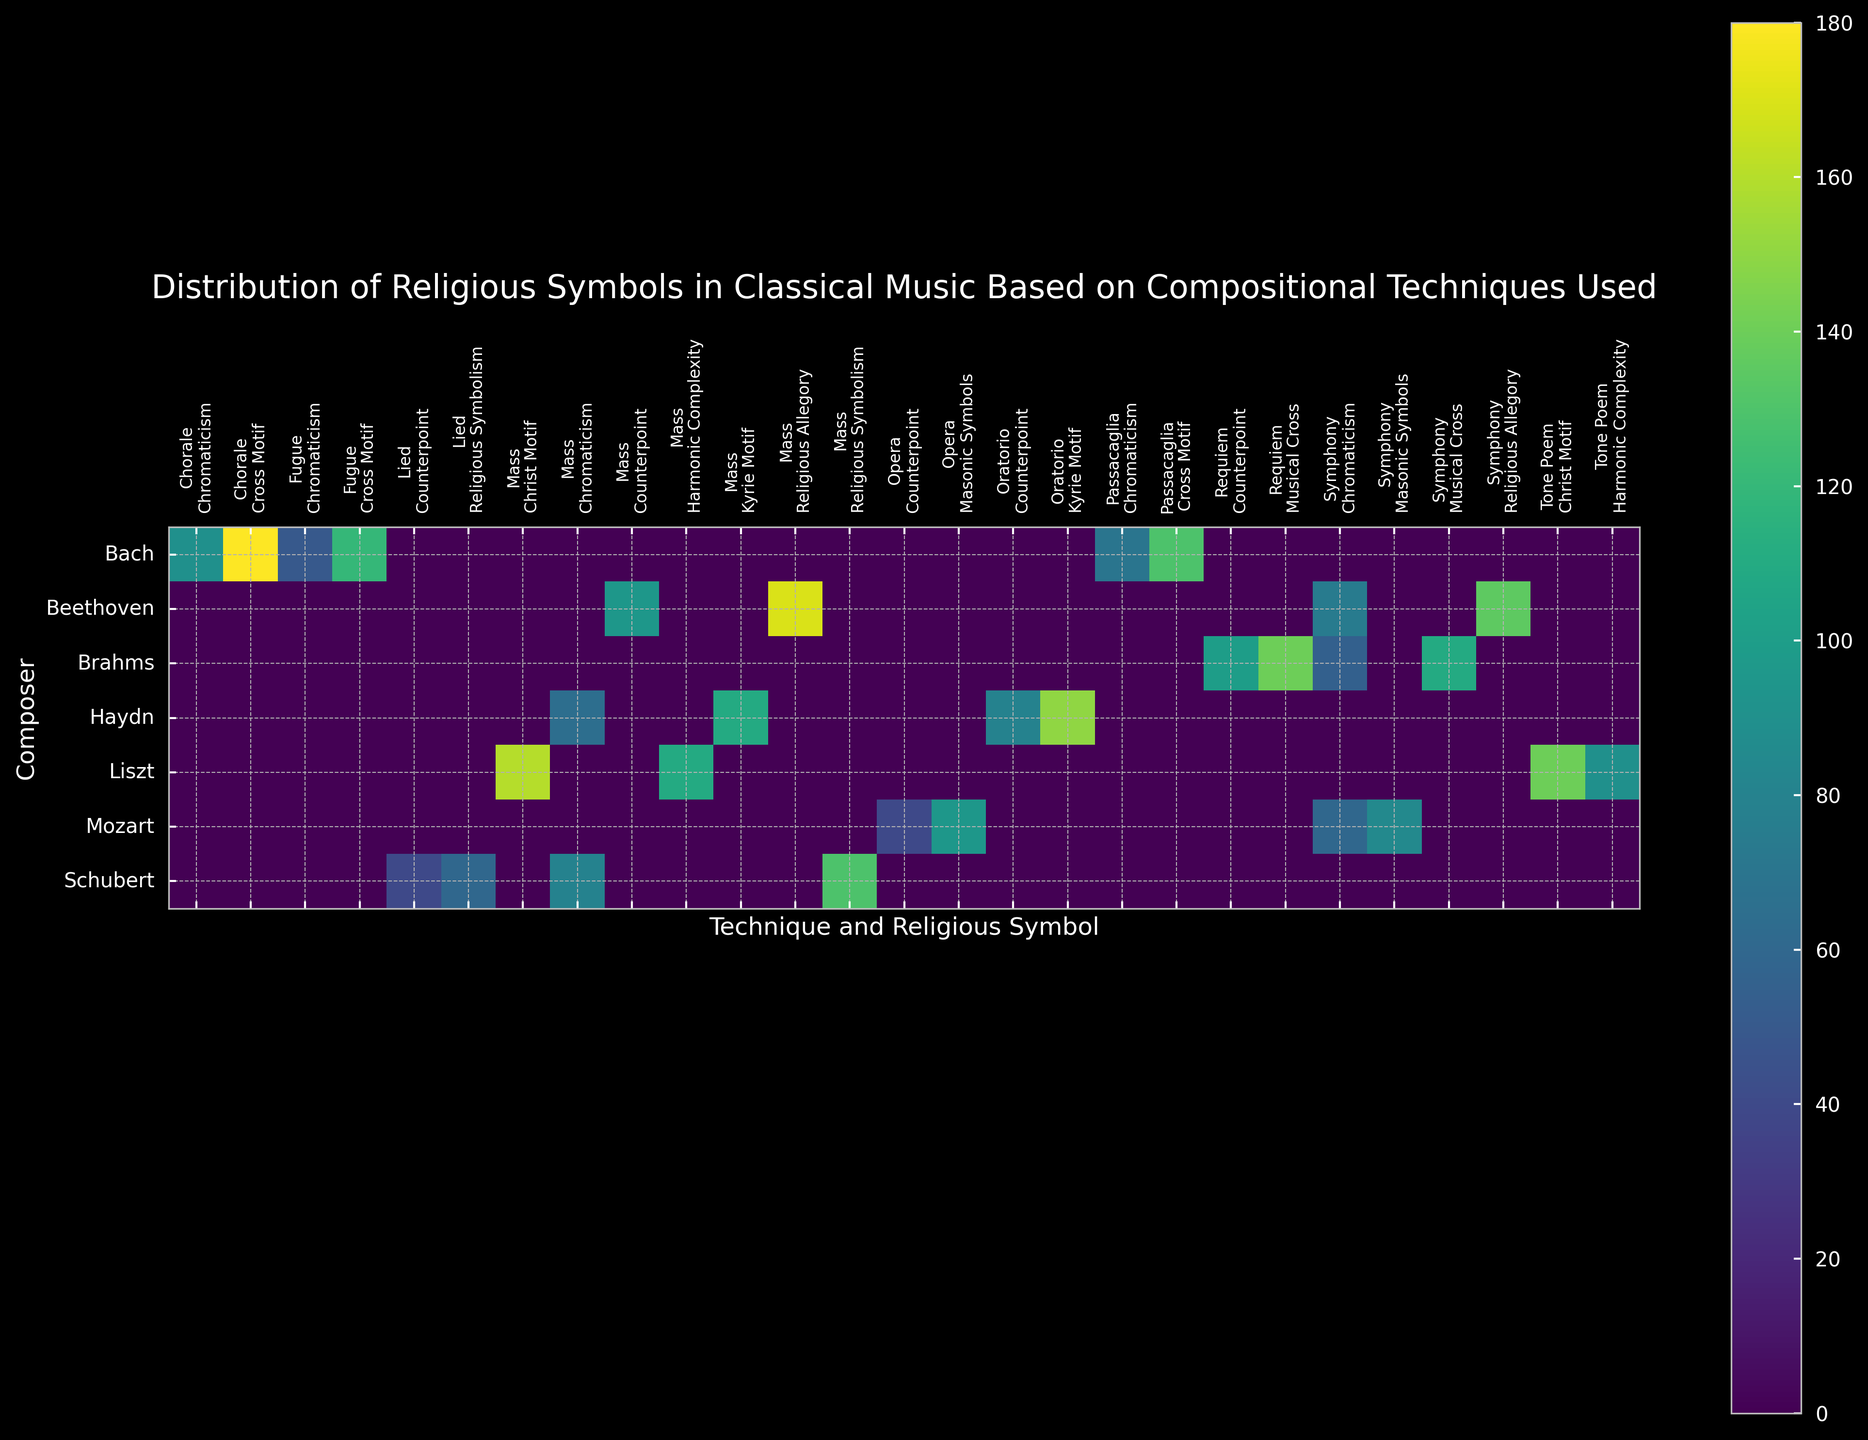What's the most frequently used religious symbol for Bach? Refer to the Bach row and identify the highest value among all religious symbols. The 'Cross Motif' in 'Chorale' has a count of 180, which is the highest.
Answer: Cross Motif How many more times does Brahms use the 'Musical Cross' in 'Requiem' compared to 'Symphony'? Identify the counts for 'Musical Cross' in both 'Requiem' and 'Symphony' for Brahms. Requiem has 140, and Symphony has 110. Subtract 110 from 140.
Answer: 30 Which compositional technique contains the highest count of religious allegory for Beethoven? Refer to Beethoven's row and compare the counts of 'Religious Allegory' in different techniques. 'Mass' has 170, while 'Symphony' has 135. Mass is higher.
Answer: Mass Does Haydn use 'Kyrie Motif' more in 'Mass' or in 'Oratorio'? Check the counts of 'Kyrie Motif' for Haydn in both techniques. 'Mass' has 110, and 'Oratorio' has 150. Oratorio is higher.
Answer: Oratorio What is the total count of chromaticism used by all composers? Sum the counts associated with 'Chromaticism' across all composers. (50+90+70+60+65+75+55+80)
Answer: 545 How does the usage of 'Masonic Symbols' in Mozart's 'Symphony' compare to 'Opera'? Compare the counts in 'Symphony' and 'Opera' for 'Masonic Symbols' in Mozart's row. Symphony has 85, and Opera has 95. Opera is higher.
Answer: Higher in Opera What is the average count of 'Religious Allegory' used by Beethoven? Check the counts of 'Religious Allegory' for Beethoven in different techniques and compute the average. Both techniques are 'Symphony' and 'Mass' with counts of 135 and 170. The sum is 305. The average is 305/2.
Answer: 152.5 Which composer has the highest overall count of religious symbols? Sum all counts for each composer and compare. Bach: 120+50+180+90+130+70 = 640. Mozart: 85+60+95+40 = 280. Haydn: 110+65+150+80 = 405. Beethoven: 135+75+170+95 = 475. Brahms: 140+100+110+55 = 405. Schubert: 130+80+60+40 = 310. Liszt: 140+90+160+110 = 500. Bach has the highest count.
Answer: Bach How does Schubert's usage of religious symbolism in 'Mass' compare to 'Lied'? Compare the counts in 'Mass' and 'Lied' for Schubert's 'Religious Symbolism'. Mass has 130, and Lied has 60. Mass is higher.
Answer: Higher in Mass What is the most common compositional technique for 'Chromaticism' across all composers? Compare the counts across all techniques for 'Chromaticism'. Fugue: 50. Chorale: 90. Passacaglia: 70. Symphony: 60+75+55 = 190. Mass: 65+80 = 145. Symphony has the highest total.
Answer: Symphony 